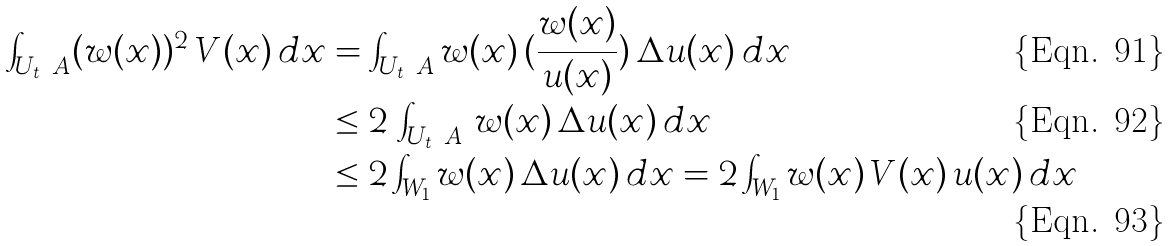<formula> <loc_0><loc_0><loc_500><loc_500>\int _ { U _ { t } \ A } ( w ( x ) ) ^ { 2 } \, V ( x ) \, d x & = \int _ { U _ { t } \ A } w ( x ) \, ( { \frac { w ( x ) } { u ( x ) } } ) \, \Delta u ( x ) \, d x \\ & \leq 2 \, \int _ { U _ { t } \ A } \, w ( x ) \, \Delta u ( x ) \, d x \\ & \leq 2 \int _ { W _ { 1 } } w ( x ) \, \Delta u ( x ) \, d x = 2 \int _ { W _ { 1 } } w ( x ) \, V ( x ) \, u ( x ) \, d x</formula> 